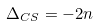<formula> <loc_0><loc_0><loc_500><loc_500>\Delta _ { C S } = - 2 n</formula> 